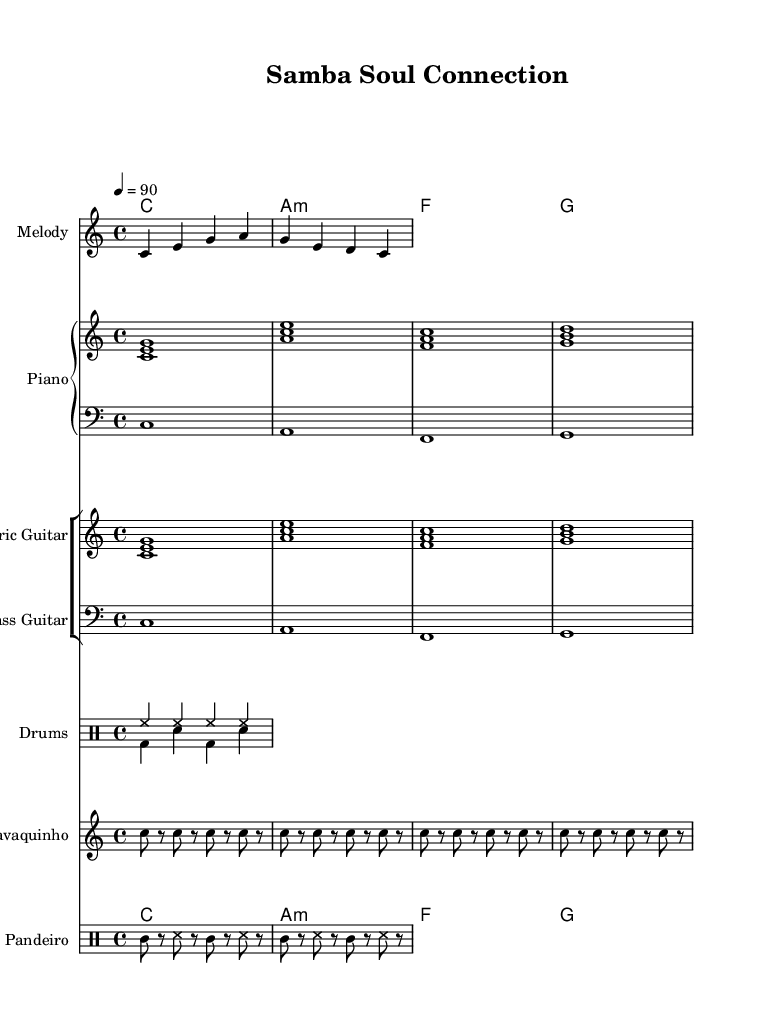What is the key signature of this music? The key signature is C major, which has no sharps or flats.
Answer: C major What is the time signature of the piece? The time signature is indicated by the "4/4" notation, which signifies four beats per measure.
Answer: 4/4 What is the tempo marking for this piece? The tempo marking is "4 = 90", which indicates the speed of the piece as 90 beats per minute.
Answer: 90 What instruments are included in this score? The score includes a melody, piano, electric guitar, bass guitar, drums, cavaquinho, and pandeiro.
Answer: Melody, Piano, Electric Guitar, Bass Guitar, Drums, Cavaquinho, Pandeiro How many measures are represented in the melody section? The melody section consists of a series of eight notes that can be grouped into two measures, as every four beats is one measure.
Answer: 2 What genre do the styles represented in this sheet music belong to? Given the combination of samba rhythms from Brazil and R&B arrangements from America, it aligns with the Rhythm and Blues genre, particularly in the context of cross-cultural collaborations.
Answer: Rhythm and Blues 